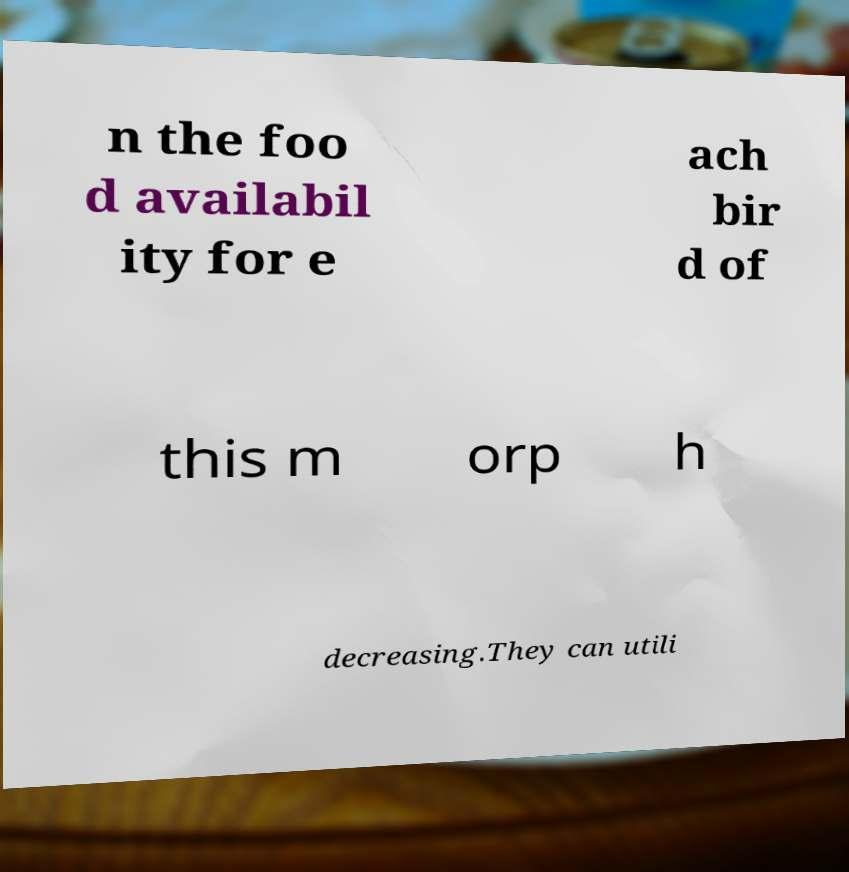Could you assist in decoding the text presented in this image and type it out clearly? n the foo d availabil ity for e ach bir d of this m orp h decreasing.They can utili 